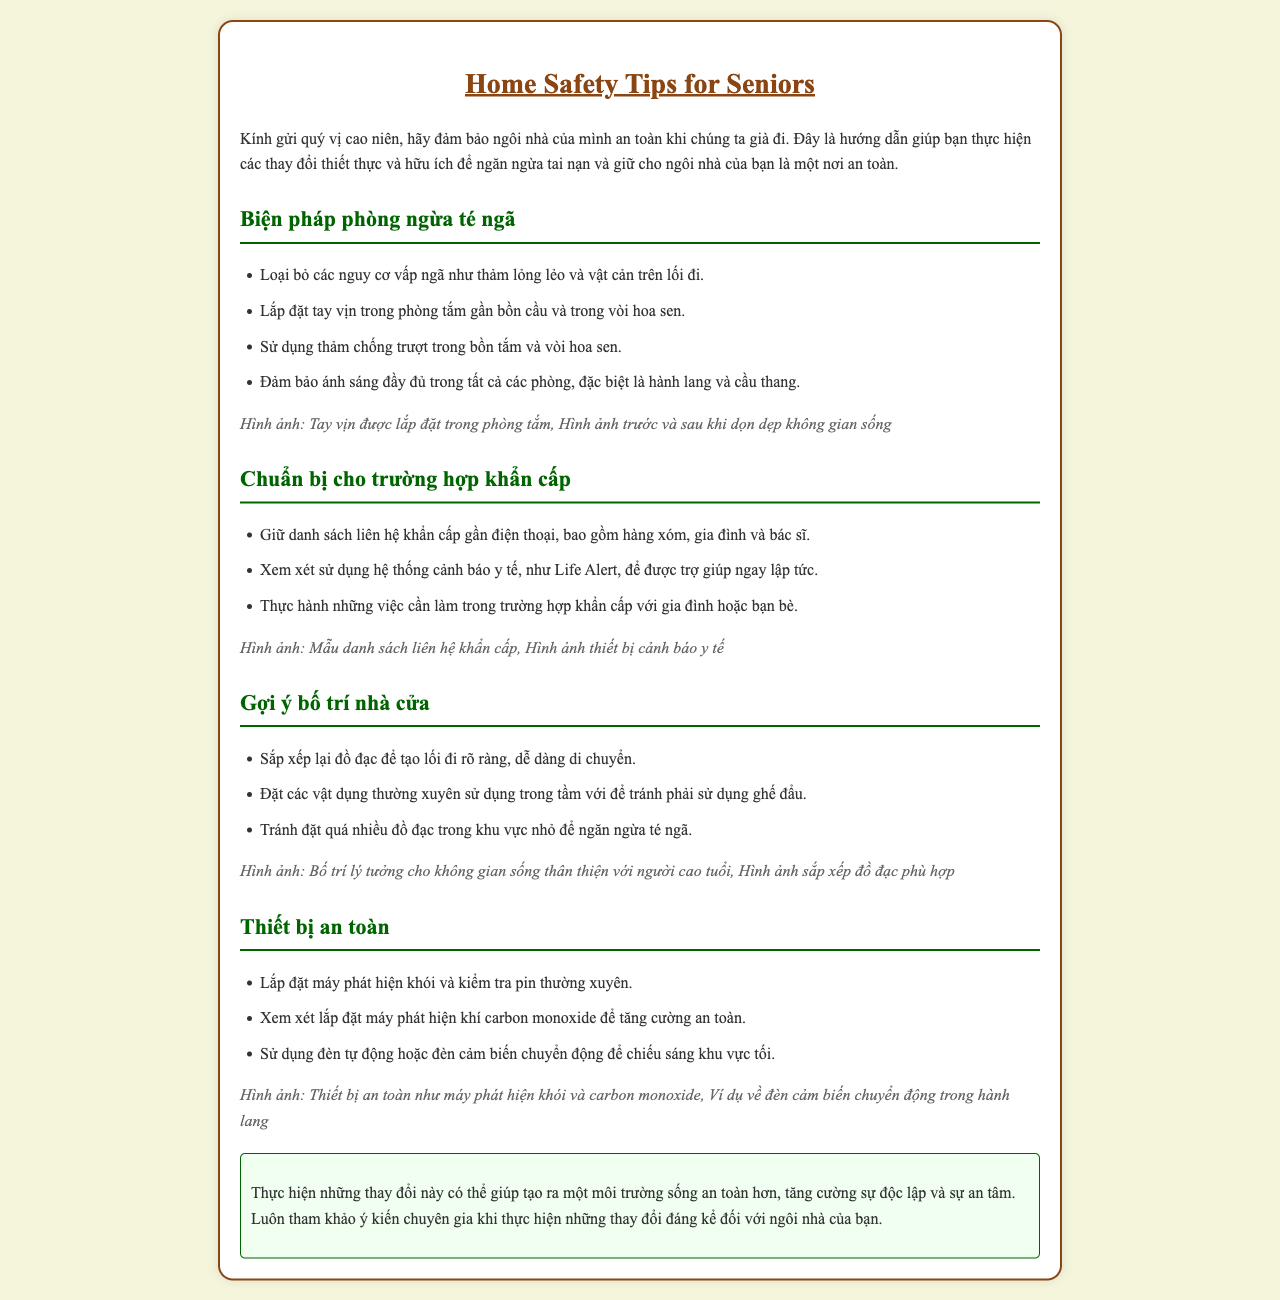What are the fall prevention measures mentioned? The document lists specific actions to prevent falls, making it a key focus area in the safety tips.
Answer: Loại bỏ các nguy cơ vấp ngã, lắp đặt tay vịn, sử dụng thảm chống trượt, đảm bảo ánh sáng đầy đủ How many suggestions are provided for home layout? The document outlines specific suggestions to optimize home layout for safety, which is crucial for seniors.
Answer: Ba (3) What should be included in the emergency contact list? The importance of emergency preparedness is highlighted, requiring specific contacts to be maintained in case of emergencies.
Answer: Hàng xóm, gia đình, bác sĩ What safety equipment is suggested for installation? The document emphasizes certain safety devices that can improve living conditions for seniors.
Answer: Máy phát hiện khói, máy phát hiện khí carbon monoxide What is the conclusion advice about making changes? The conclusion reinforces the overall message of the document and offers practical advice regarding home changes for safety.
Answer: Tham khảo ý kiến chuyên gia 